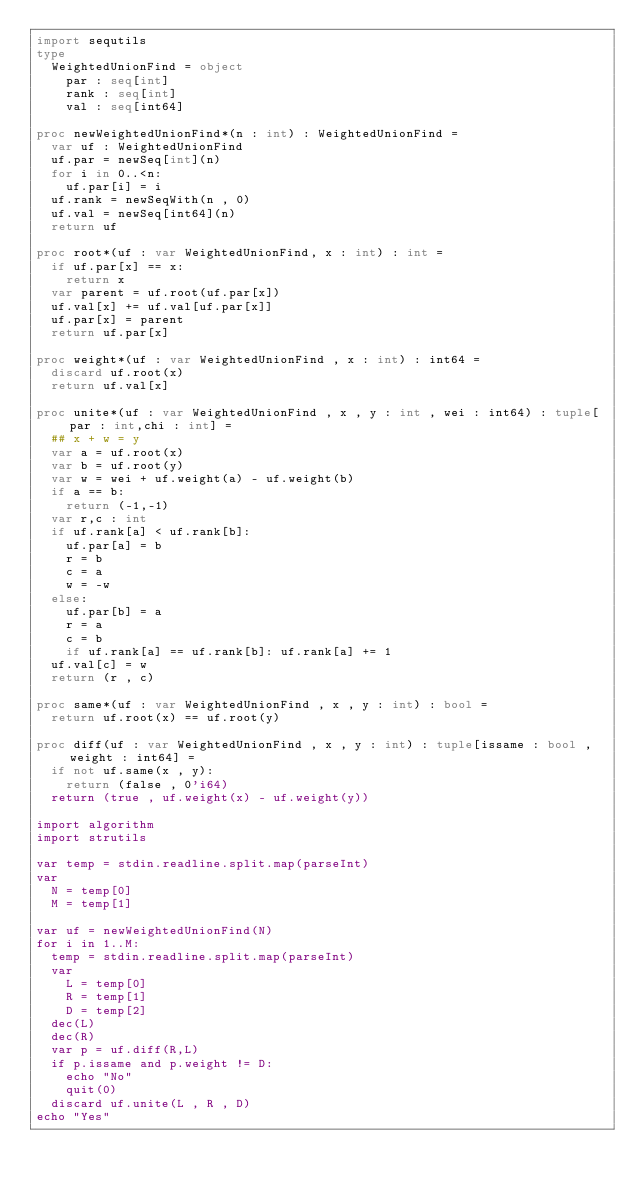<code> <loc_0><loc_0><loc_500><loc_500><_Nim_>import sequtils
type
  WeightedUnionFind = object
    par : seq[int]
    rank : seq[int]
    val : seq[int64]

proc newWeightedUnionFind*(n : int) : WeightedUnionFind =
  var uf : WeightedUnionFind
  uf.par = newSeq[int](n)
  for i in 0..<n:
    uf.par[i] = i
  uf.rank = newSeqWith(n , 0)
  uf.val = newSeq[int64](n)
  return uf

proc root*(uf : var WeightedUnionFind, x : int) : int =
  if uf.par[x] == x:
    return x
  var parent = uf.root(uf.par[x])
  uf.val[x] += uf.val[uf.par[x]]
  uf.par[x] = parent
  return uf.par[x]

proc weight*(uf : var WeightedUnionFind , x : int) : int64 =
  discard uf.root(x)
  return uf.val[x]

proc unite*(uf : var WeightedUnionFind , x , y : int , wei : int64) : tuple[par : int,chi : int] =
  ## x + w = y
  var a = uf.root(x)
  var b = uf.root(y)
  var w = wei + uf.weight(a) - uf.weight(b)
  if a == b:
    return (-1,-1)
  var r,c : int
  if uf.rank[a] < uf.rank[b]:
    uf.par[a] = b
    r = b
    c = a
    w = -w
  else:
    uf.par[b] = a
    r = a
    c = b
    if uf.rank[a] == uf.rank[b]: uf.rank[a] += 1
  uf.val[c] = w
  return (r , c)

proc same*(uf : var WeightedUnionFind , x , y : int) : bool =
  return uf.root(x) == uf.root(y)

proc diff(uf : var WeightedUnionFind , x , y : int) : tuple[issame : bool , weight : int64] =
  if not uf.same(x , y):
    return (false , 0'i64)
  return (true , uf.weight(x) - uf.weight(y))

import algorithm
import strutils

var temp = stdin.readline.split.map(parseInt)
var 
  N = temp[0]
  M = temp[1]

var uf = newWeightedUnionFind(N)
for i in 1..M:
  temp = stdin.readline.split.map(parseInt)
  var
    L = temp[0]
    R = temp[1]
    D = temp[2]
  dec(L)
  dec(R)
  var p = uf.diff(R,L)
  if p.issame and p.weight != D:
    echo "No"
    quit(0)
  discard uf.unite(L , R , D)
echo "Yes"

</code> 